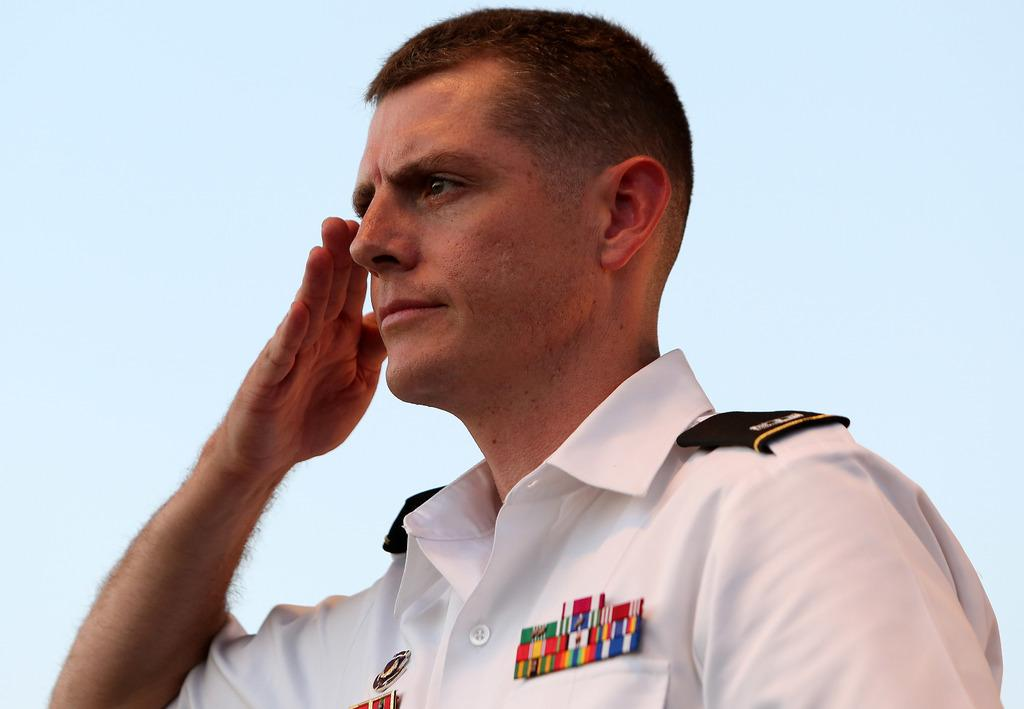Who is present in the image? There is a man in the image. What is the man doing in the image? The man is saluting. What can be seen in the background of the image? There is sky visible in the background of the image. What type of ship can be seen in the image? There is no ship present in the image; it only features a man saluting with sky visible in the background. 